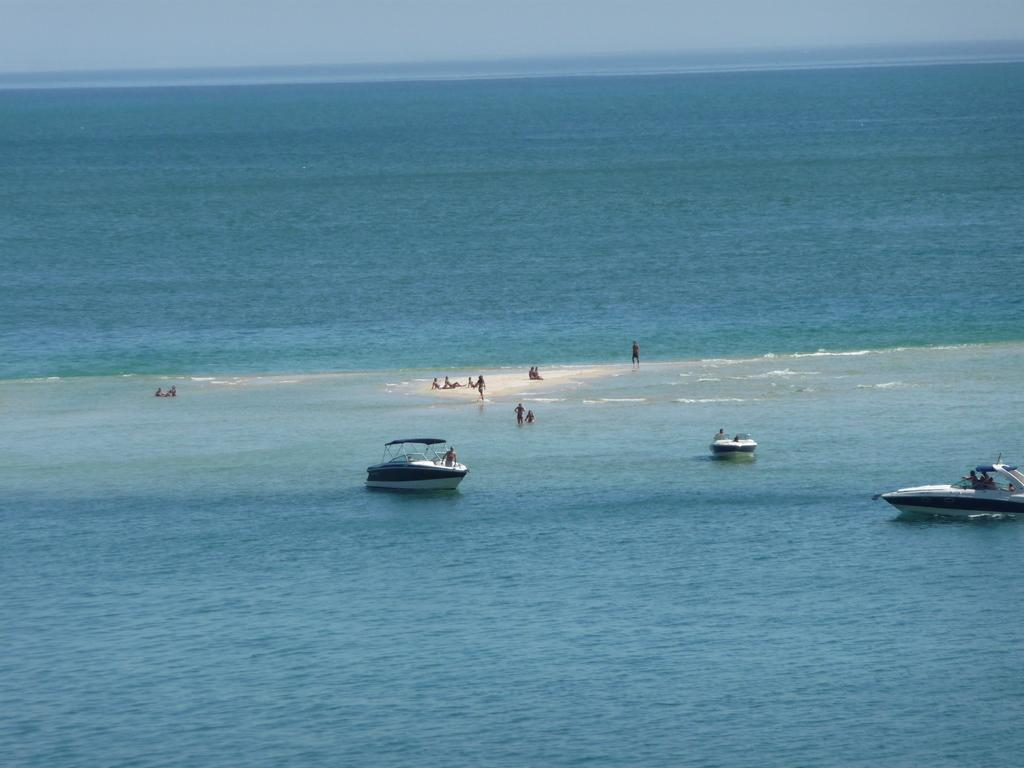What is the primary element visible in the image? There is water in the image. What are the people in the image doing? There are many people in the water. Are there any objects floating on the water? Yes, there are boats on the water. What type of butter is being used by the minister in the image? There is no minister or butter present in the image. 